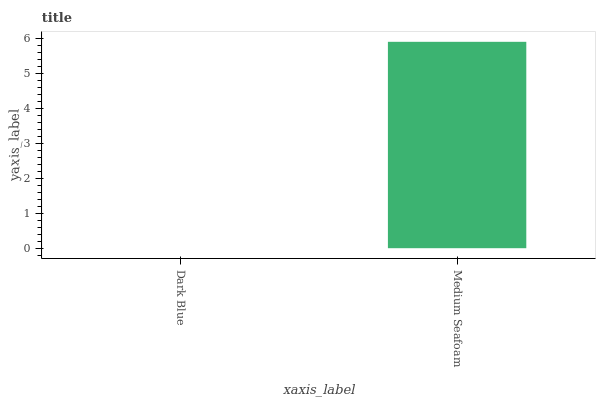Is Dark Blue the minimum?
Answer yes or no. Yes. Is Medium Seafoam the maximum?
Answer yes or no. Yes. Is Medium Seafoam the minimum?
Answer yes or no. No. Is Medium Seafoam greater than Dark Blue?
Answer yes or no. Yes. Is Dark Blue less than Medium Seafoam?
Answer yes or no. Yes. Is Dark Blue greater than Medium Seafoam?
Answer yes or no. No. Is Medium Seafoam less than Dark Blue?
Answer yes or no. No. Is Medium Seafoam the high median?
Answer yes or no. Yes. Is Dark Blue the low median?
Answer yes or no. Yes. Is Dark Blue the high median?
Answer yes or no. No. Is Medium Seafoam the low median?
Answer yes or no. No. 